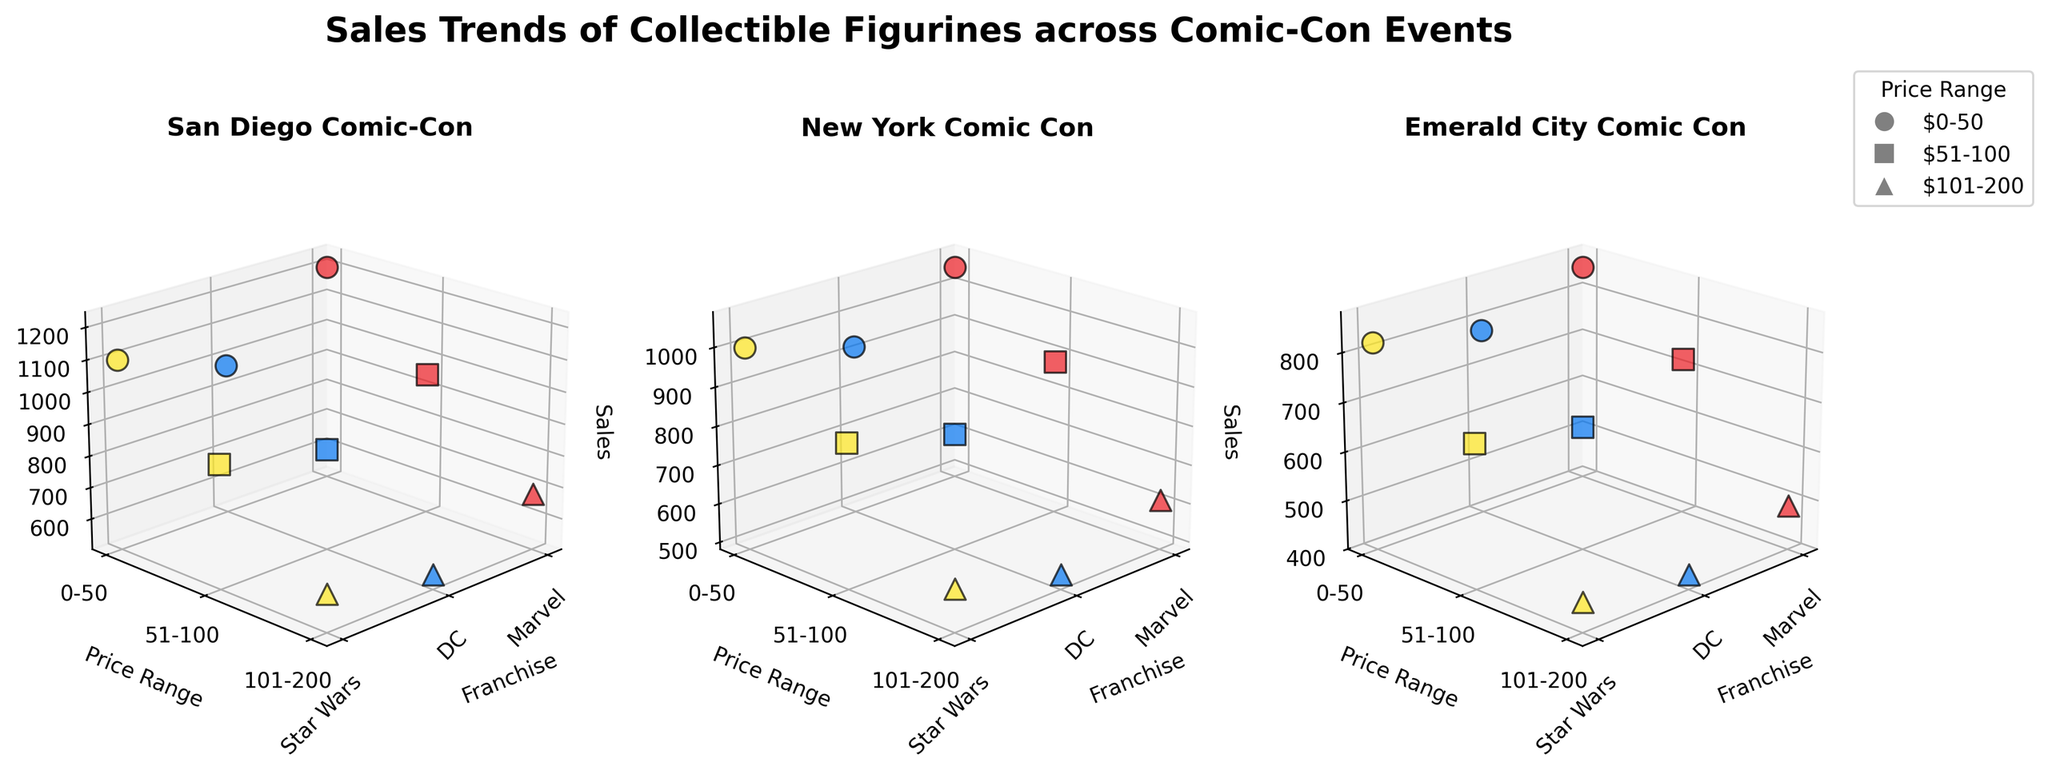What franchises are shown in the plot? The x-axis labels indicate the franchises shown in the plot, which are Marvel, DC, and Star Wars.
Answer: Marvel, DC, Star Wars What are the price ranges for the collectible figurines? The y-axis labels indicate the price ranges for the collectible figurines, which are $0-50, $51-100, and $101-200.
Answer: $0-50, $51-100, $101-200 Which Comic-Con event had the highest sales for Marvel figurines in the $51-100 price range? The highest sales for Marvel figurines in the $51-100 price range can be determined by looking at the sales figures for each Comic-Con event. The San Diego Comic-Con event has the highest sales figure for this category with 950 units sold.
Answer: San Diego Comic-Con How do the sales of DC figurines in the $0-50 price range compare across the three Comic-Con events? By comparing the sales figures for DC figurines in the $0-50 price range across the three Comic-Con events: San Diego Comic-Con (980), New York Comic Con (920), and Emerald City Comic Con (780), it's evident that San Diego Comic-Con has the highest sales, followed by New York Comic Con and Emerald City Comic Con.
Answer: 980 (San Diego), 920 (New York), 780 (Emerald City) What is the trend in sales for Star Wars figurines across the three Comic-Con events? To find the trend in sales for Star Wars figurines across the three Comic-Con events, we observe that sales in each price range are highest at San Diego Comic-Con, followed by New York Comic Con, and lowest at Emerald City Comic Con. For $0-50: 1100 (San Diego), 1000 (New York), 820 (Emerald City). For $51-100: 890 (San Diego), 850 (New York), 690 (Emerald City). For $101-200: 620 (San Diego), 590 (New York), 460 (Emerald City).
Answer: Decreasing trend: San Diego > New York > Emerald City Which franchise has the lowest total sales in the $101-200 price range? By summing the sales figures for the $101-200 price range across all Comic-Con events for each franchise: Marvel (680+610+490 = 1780), DC (550+520+430 = 1500), and Star Wars (620+590+460 = 1670), we find that DC has the lowest total sales.
Answer: DC Compare the sales of Marvel figurines in the $0-50 price range versus the $101-200 price range at San Diego Comic-Con. The sales figure for Marvel figurines in the $0-50 price range at San Diego Comic-Con is 1200, while the sales figure for the $101-200 price range is 680.
Answer: 1200 (0-50), 680 (101-200) What is the average sales figure for DC figurines across all price ranges at New York Comic Con? The sales figures for DC figurines across all price ranges at New York Comic Con are 920 ($0-50), 780 ($51-100), and 520 ($101-200). To find the average, sum these values and divide by 3: (920 + 780 + 520) / 3 = 2200 / 3 = 733.33.
Answer: 733.33 Identify the highest sales figure among all the events and categories. To find the highest sales figure, compare the sales values across all events and categories. The highest sales figure is 1200 for Marvel figurines in the $0-50 price range at San Diego Comic-Con.
Answer: 1200 